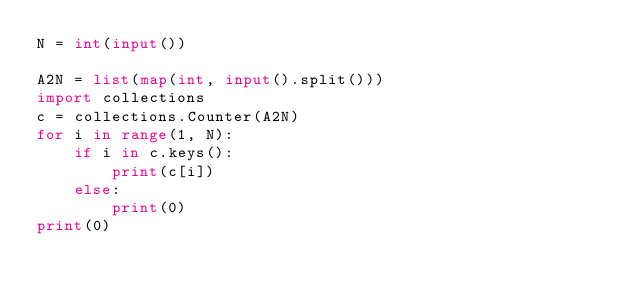Convert code to text. <code><loc_0><loc_0><loc_500><loc_500><_Python_>N = int(input())

A2N = list(map(int, input().split()))
import collections
c = collections.Counter(A2N)
for i in range(1, N):
    if i in c.keys():
        print(c[i])
    else:
        print(0)
print(0)</code> 